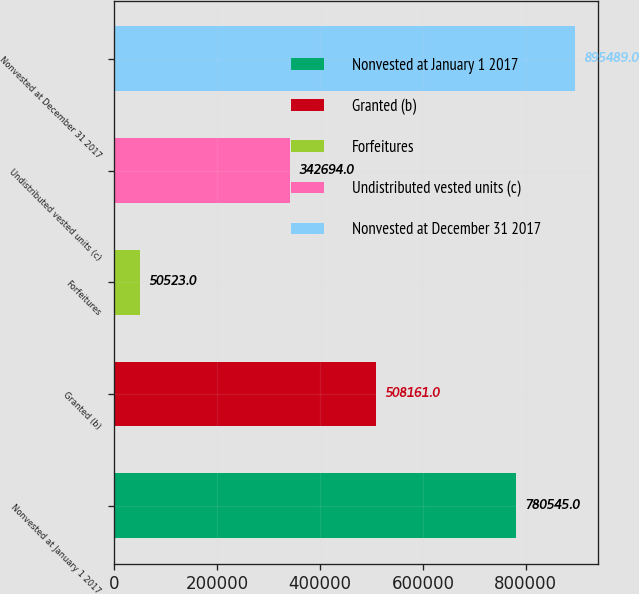<chart> <loc_0><loc_0><loc_500><loc_500><bar_chart><fcel>Nonvested at January 1 2017<fcel>Granted (b)<fcel>Forfeitures<fcel>Undistributed vested units (c)<fcel>Nonvested at December 31 2017<nl><fcel>780545<fcel>508161<fcel>50523<fcel>342694<fcel>895489<nl></chart> 